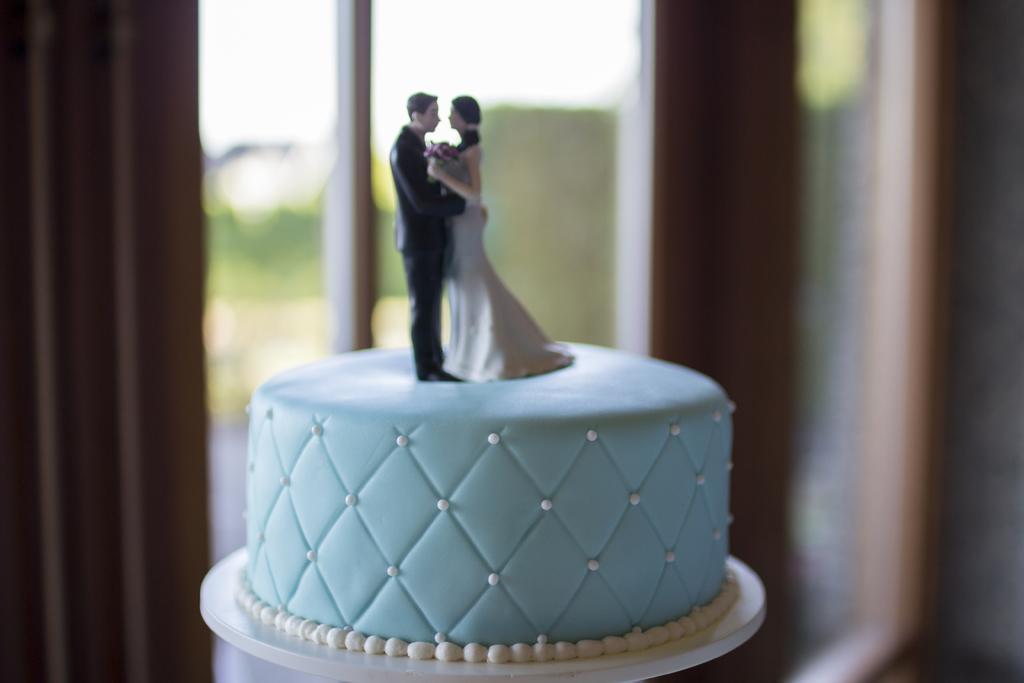Describe this image in one or two sentences. This image consists of a cake on which there are idols of man and woman. In the background, there is a window along with a curtain. 